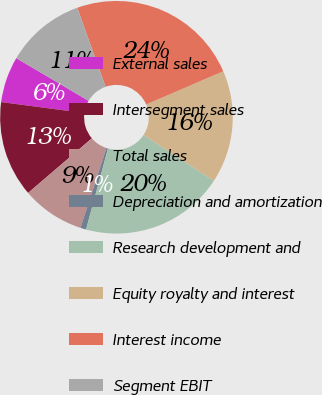Convert chart to OTSL. <chart><loc_0><loc_0><loc_500><loc_500><pie_chart><fcel>External sales<fcel>Intersegment sales<fcel>Total sales<fcel>Depreciation and amortization<fcel>Research development and<fcel>Equity royalty and interest<fcel>Interest income<fcel>Segment EBIT<nl><fcel>6.4%<fcel>13.36%<fcel>8.72%<fcel>0.8%<fcel>20.0%<fcel>15.68%<fcel>24.0%<fcel>11.04%<nl></chart> 